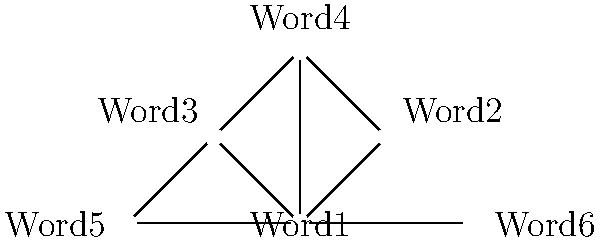In the graph above, which represents word associations across multiple languages, identify the most central node using the concept of degree centrality. Explain your reasoning based on the graph structure and its implications for cross-lingual semantic relationships. To determine the most central node using degree centrality, we need to follow these steps:

1. Understand degree centrality:
   Degree centrality is a measure of the number of direct connections a node has to other nodes in the graph.

2. Count the connections for each node:
   - Word1: 5 connections
   - Word2: 2 connections
   - Word3: 3 connections
   - Word4: 3 connections
   - Word5: 3 connections
   - Word6: 2 connections

3. Identify the node with the highest degree:
   Word1 has the highest degree with 5 connections.

4. Interpret the results:
   - Word1 is the most central node based on degree centrality.
   - This suggests that Word1 has the most direct associations with other words across the languages represented in the graph.
   - In the context of cross-lingual semantics, Word1 might represent a concept that is highly connected or fundamental across multiple languages.
   - This high centrality could indicate that Word1 is a key term for understanding semantic relationships between the languages in the study.

5. Consider implications for machine learning applications:
   - In natural language processing tasks, Words like Word1 could be crucial for building cross-lingual models or for transfer learning between languages.
   - The high centrality of Word1 might make it a good candidate for anchoring cross-lingual word embeddings or for initiating word sense disambiguation across languages.
Answer: Word1 